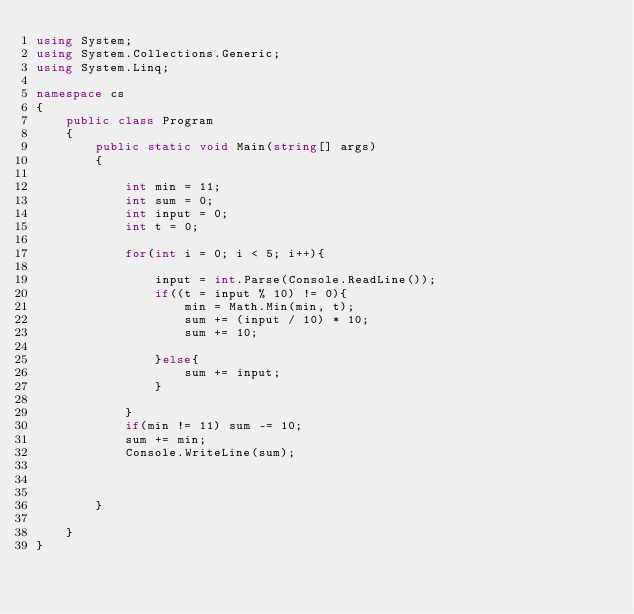Convert code to text. <code><loc_0><loc_0><loc_500><loc_500><_C#_>using System;
using System.Collections.Generic;
using System.Linq;

namespace cs
{
    public class Program
    {
        public static void Main(string[] args)
        {
        
        	int min = 11;
        	int sum = 0;
        	int input = 0;
        	int t = 0;
        	
        	for(int i = 0; i < 5; i++){
        		
        		input = int.Parse(Console.ReadLine());
        		if((t = input % 10) != 0){
        			min = Math.Min(min, t);
        			sum += (input / 10) * 10;
        			sum += 10;
        		
        		}else{
        			sum += input;
        		}
        	
        	}
        	if(min != 11) sum -= 10;
        	sum += min;
        	Console.WriteLine(sum);
        
        
        
        }
            
    }
}

</code> 